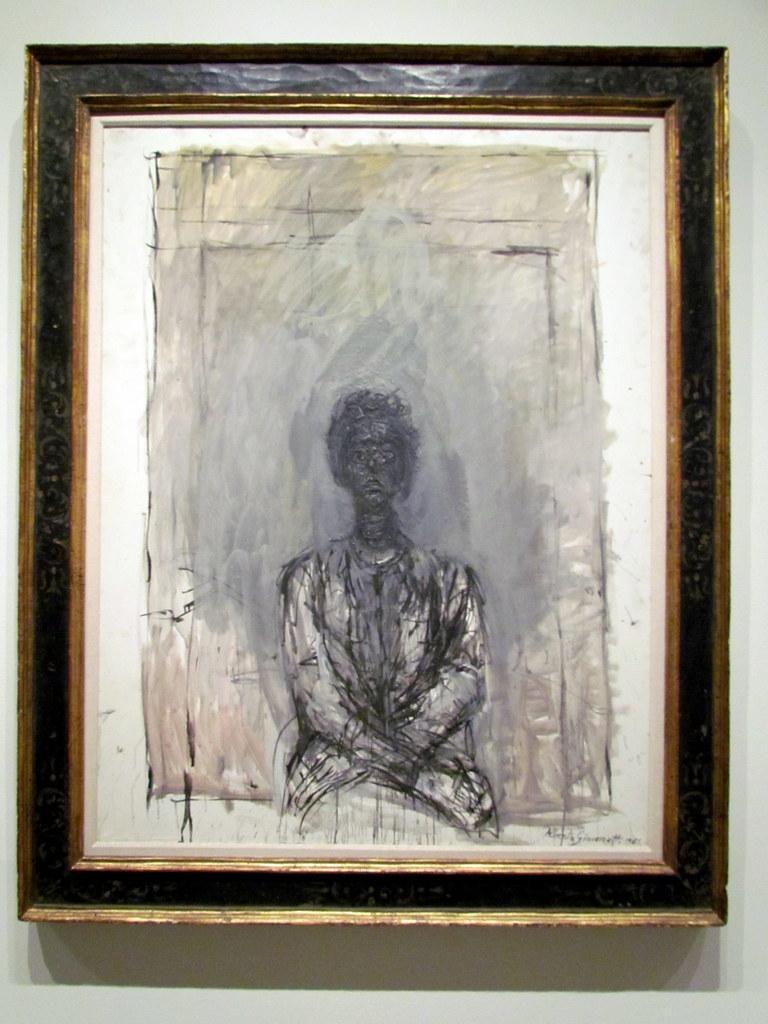In one or two sentences, can you explain what this image depicts? In this picture I can see a photo frame and on the frame I see the drawing of a person and I see this frame is on the white color surface. 